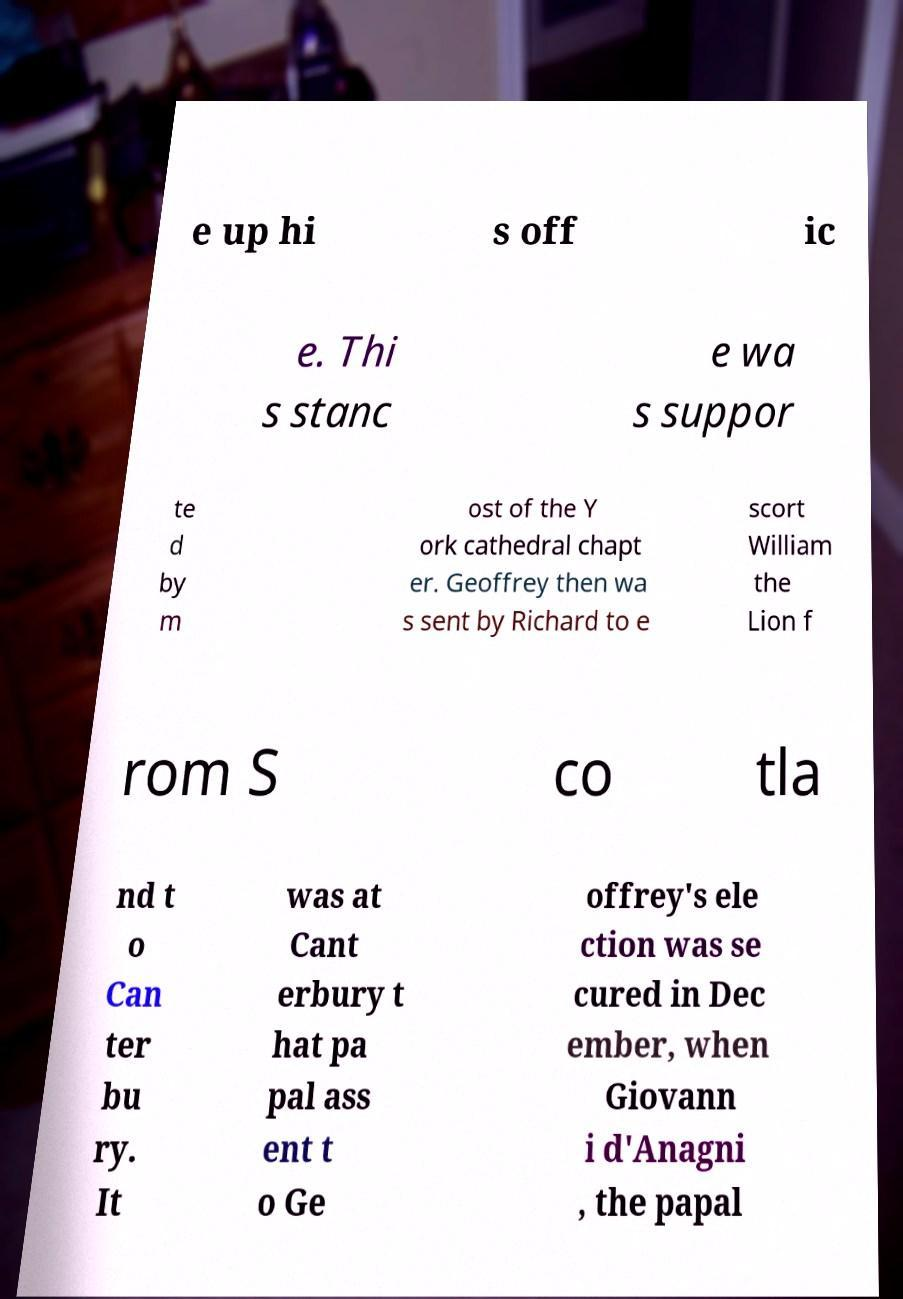What messages or text are displayed in this image? I need them in a readable, typed format. e up hi s off ic e. Thi s stanc e wa s suppor te d by m ost of the Y ork cathedral chapt er. Geoffrey then wa s sent by Richard to e scort William the Lion f rom S co tla nd t o Can ter bu ry. It was at Cant erbury t hat pa pal ass ent t o Ge offrey's ele ction was se cured in Dec ember, when Giovann i d'Anagni , the papal 